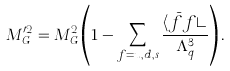Convert formula to latex. <formula><loc_0><loc_0><loc_500><loc_500>M _ { G } ^ { \prime 2 } = M _ { G } ^ { 2 } \left ( 1 - \sum _ { f = u , d , s } \frac { \langle \bar { f } f \rangle } { \Lambda _ { q } ^ { 3 } } \right ) .</formula> 